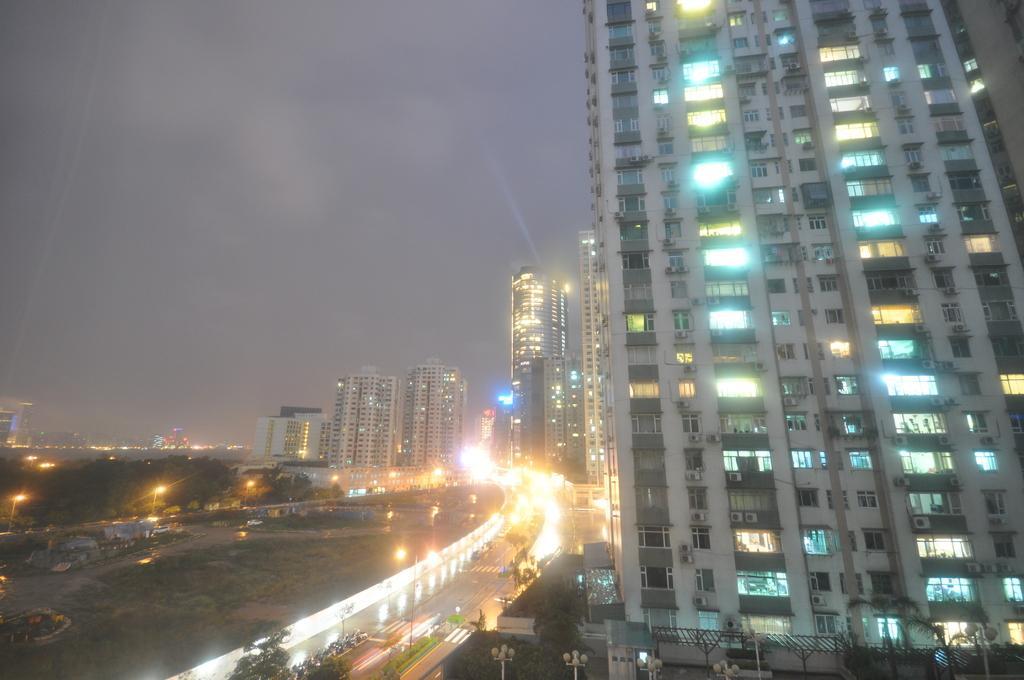How would you summarize this image in a sentence or two? In the image in the center we can see buildings,lights,windows,trees,poles,few vehicles,plants,grass,tents,road and ground. In the background we can see the sky and clouds. 